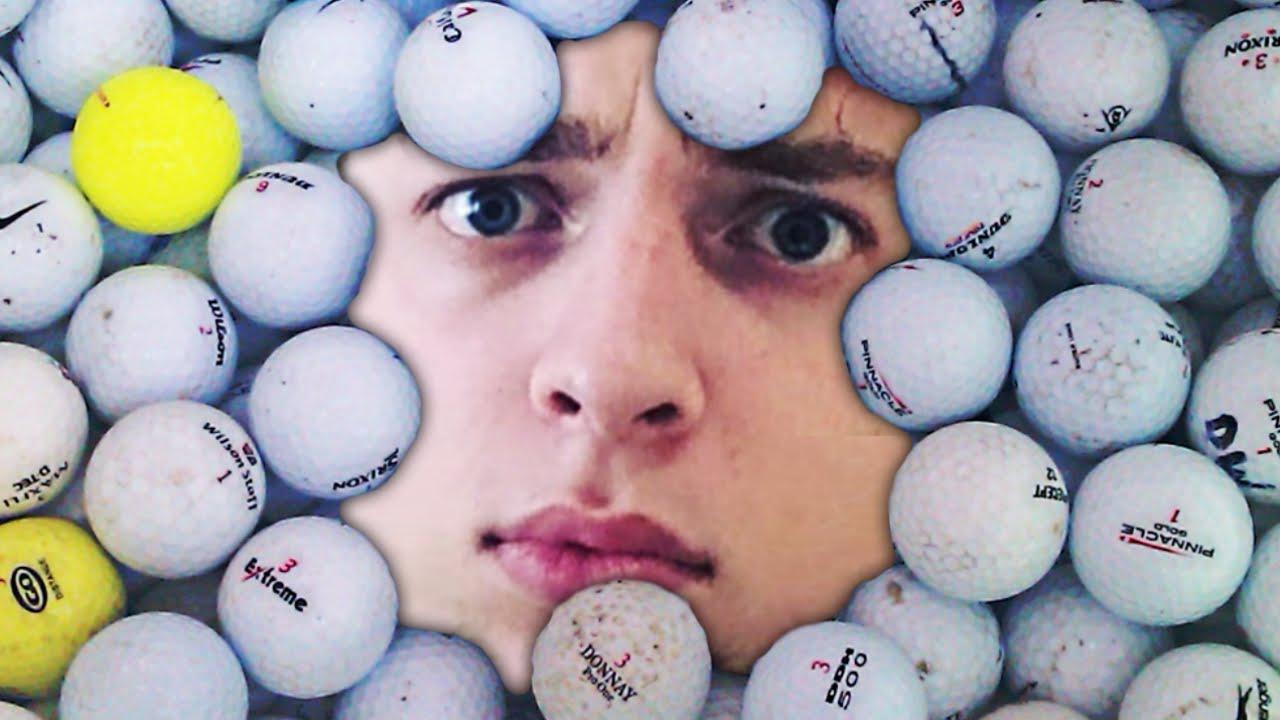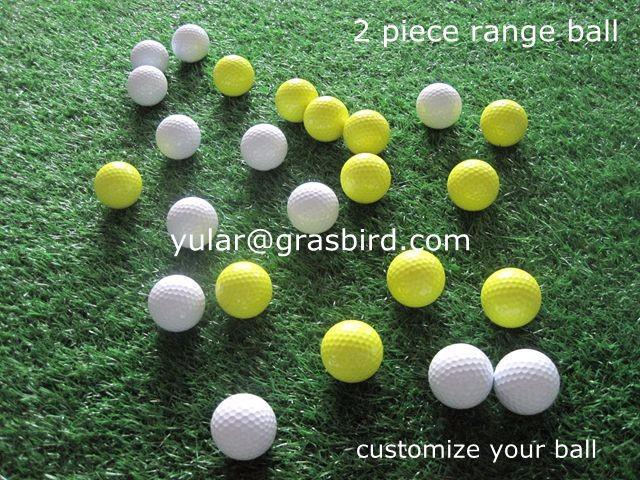The first image is the image on the left, the second image is the image on the right. For the images displayed, is the sentence "An image shows yellow and orange balls among white golf balls." factually correct? Answer yes or no. No. The first image is the image on the left, the second image is the image on the right. Examine the images to the left and right. Is the description "All the balls in the image on the right are white." accurate? Answer yes or no. No. 